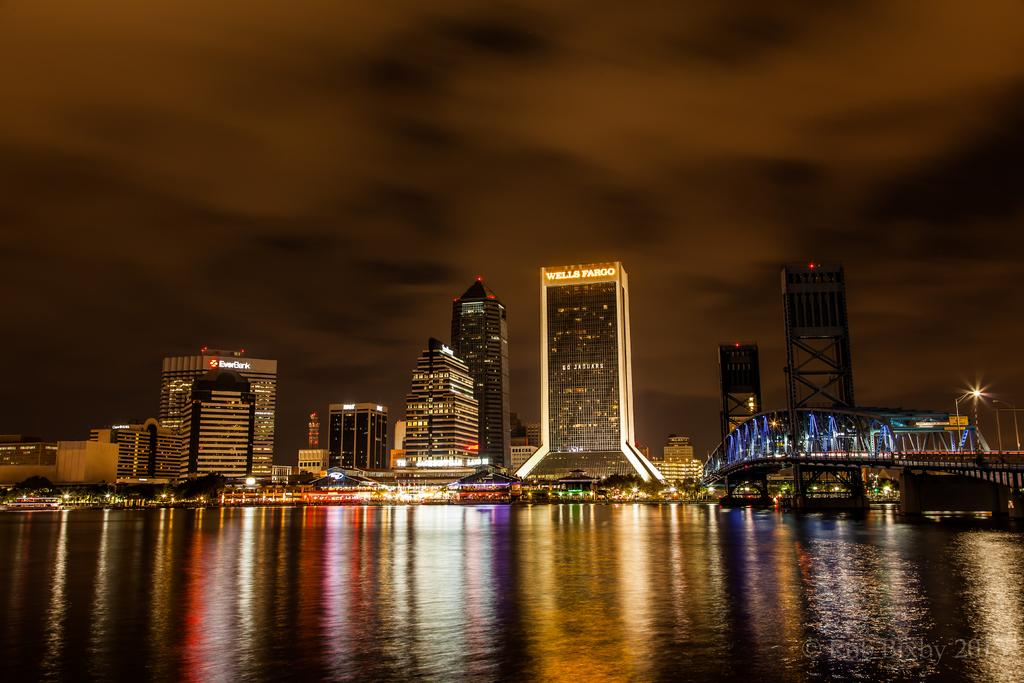<image>
Give a short and clear explanation of the subsequent image. A city sky line at night containg a bridge and the Everbank building. 